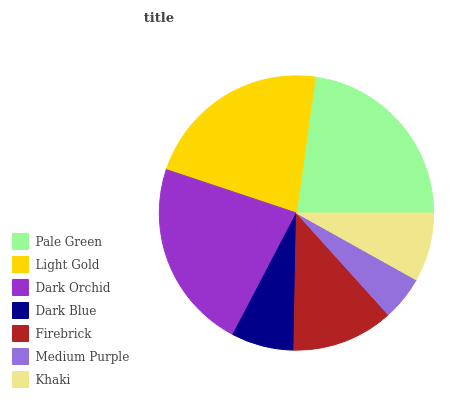Is Medium Purple the minimum?
Answer yes or no. Yes. Is Pale Green the maximum?
Answer yes or no. Yes. Is Light Gold the minimum?
Answer yes or no. No. Is Light Gold the maximum?
Answer yes or no. No. Is Pale Green greater than Light Gold?
Answer yes or no. Yes. Is Light Gold less than Pale Green?
Answer yes or no. Yes. Is Light Gold greater than Pale Green?
Answer yes or no. No. Is Pale Green less than Light Gold?
Answer yes or no. No. Is Firebrick the high median?
Answer yes or no. Yes. Is Firebrick the low median?
Answer yes or no. Yes. Is Pale Green the high median?
Answer yes or no. No. Is Light Gold the low median?
Answer yes or no. No. 